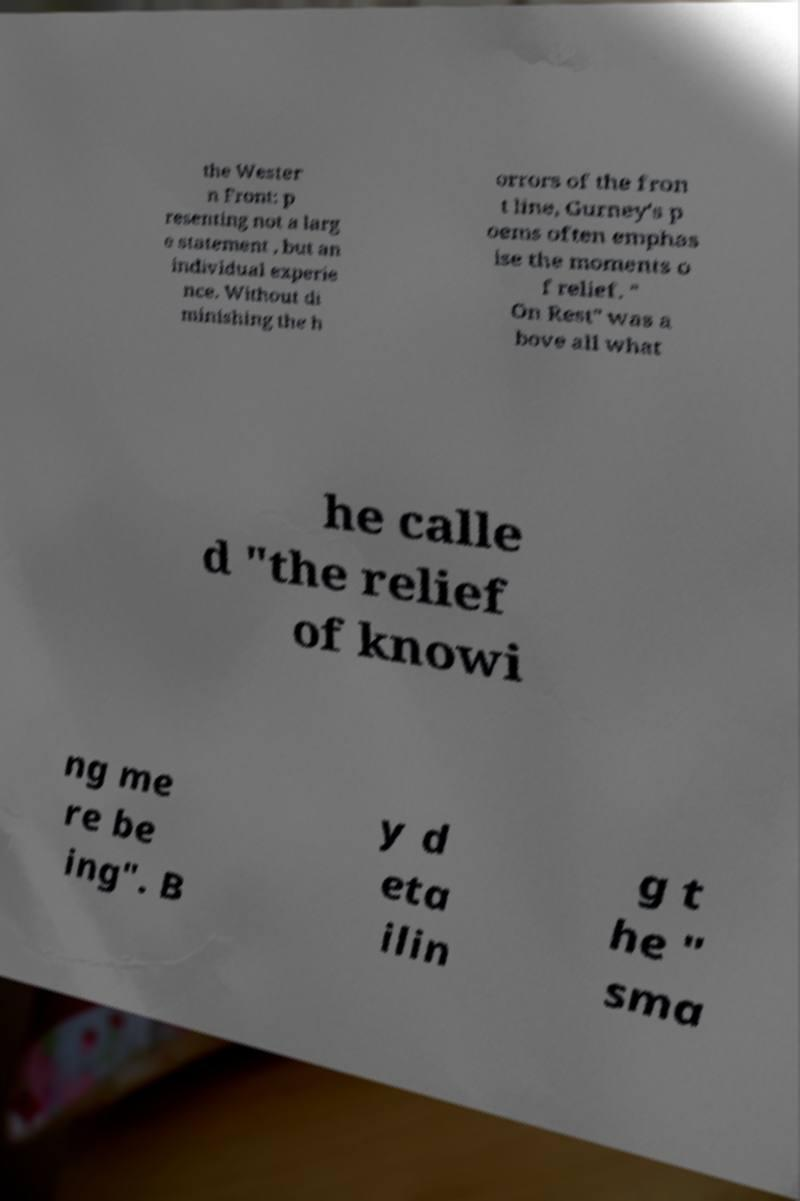What messages or text are displayed in this image? I need them in a readable, typed format. the Wester n Front: p resenting not a larg e statement , but an individual experie nce. Without di minishing the h orrors of the fron t line, Gurney's p oems often emphas ise the moments o f relief. " On Rest" was a bove all what he calle d "the relief of knowi ng me re be ing". B y d eta ilin g t he " sma 